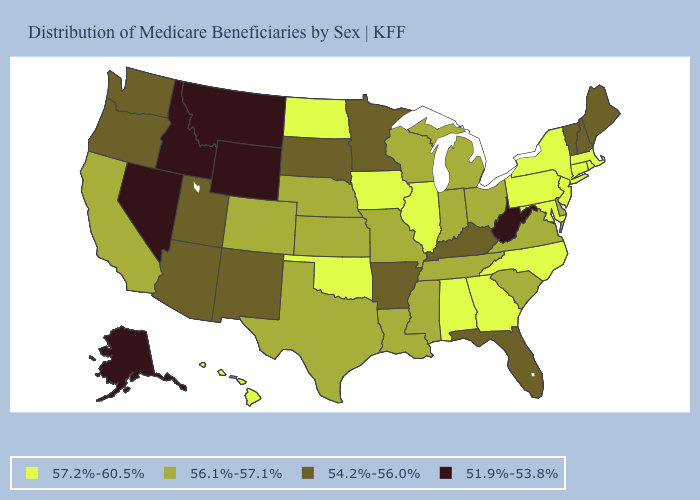What is the value of Iowa?
Keep it brief. 57.2%-60.5%. What is the lowest value in the USA?
Keep it brief. 51.9%-53.8%. What is the value of Georgia?
Write a very short answer. 57.2%-60.5%. What is the value of Vermont?
Write a very short answer. 54.2%-56.0%. What is the value of Oregon?
Keep it brief. 54.2%-56.0%. What is the value of Iowa?
Keep it brief. 57.2%-60.5%. What is the lowest value in the USA?
Give a very brief answer. 51.9%-53.8%. Name the states that have a value in the range 57.2%-60.5%?
Be succinct. Alabama, Connecticut, Georgia, Hawaii, Illinois, Iowa, Maryland, Massachusetts, New Jersey, New York, North Carolina, North Dakota, Oklahoma, Pennsylvania, Rhode Island. Does New Mexico have the same value as Washington?
Answer briefly. Yes. What is the highest value in the West ?
Write a very short answer. 57.2%-60.5%. Does South Carolina have the lowest value in the South?
Quick response, please. No. Does the map have missing data?
Concise answer only. No. What is the value of Alaska?
Short answer required. 51.9%-53.8%. What is the value of South Carolina?
Write a very short answer. 56.1%-57.1%. Name the states that have a value in the range 56.1%-57.1%?
Short answer required. California, Colorado, Delaware, Indiana, Kansas, Louisiana, Michigan, Mississippi, Missouri, Nebraska, Ohio, South Carolina, Tennessee, Texas, Virginia, Wisconsin. 